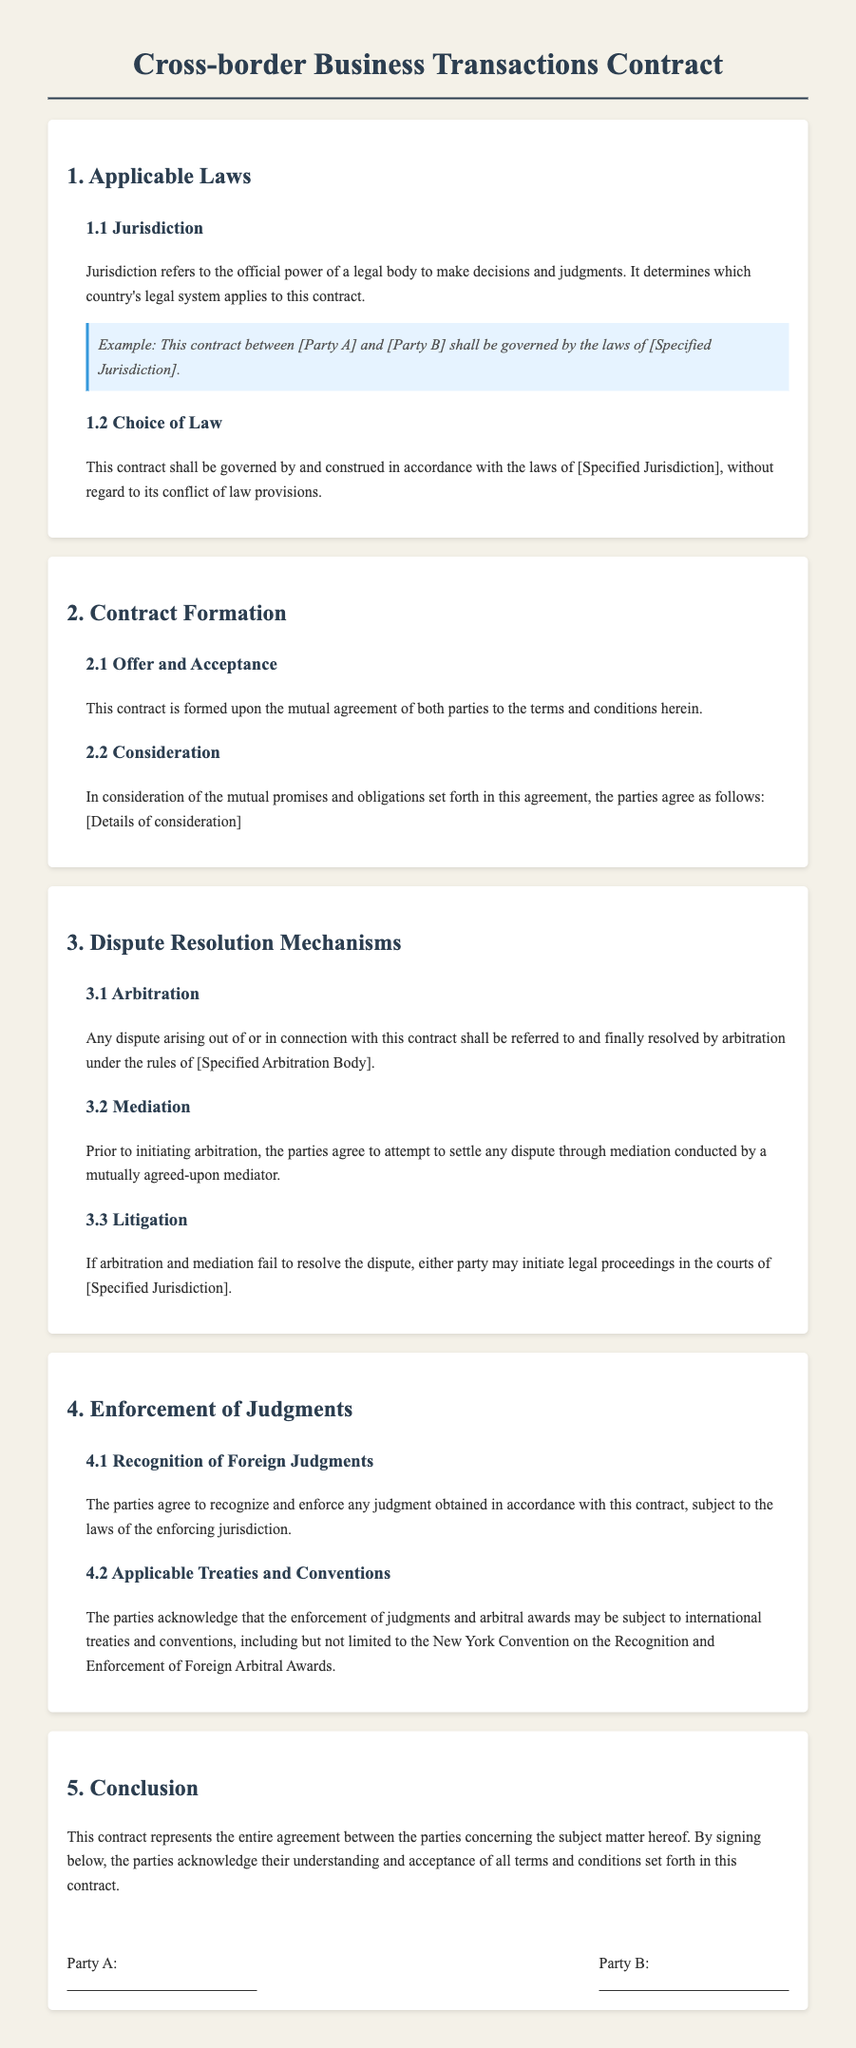What is the title of the contract? The title of the contract is highlighted at the top of the document, outlining the focus of the agreement.
Answer: Cross-border Business Transactions Contract What is specified in section 1.1? Section 1.1 discusses the concept of jurisdiction and its importance in determining the applicable legal framework for the contract.
Answer: Jurisdiction Who governs the laws applied to the contract? The document specifies who governs the laws applicable to the contract in section 1.2.
Answer: Specified Jurisdiction What dispute resolution method is mentioned first? The first dispute resolution method listed in section 3 is a process that involves an independent third party resolving a dispute.
Answer: Arbitration What is the final conclusion regarding the contract? The conclusion of the contract affirms the understanding and acceptance of all parties involved regarding its terms.
Answer: Entire agreement What is required before initiating arbitration? The document specifies a step that needs to be taken before arbitration can begin in section 3.2.
Answer: Mediation In which section is the enforcement of judgments discussed? This section discusses how judgments will be recognized and enforced based on the agreement.
Answer: Section 4 What convention is acknowledged for enforcing judgments? This international agreement mentioned in section 4.2 pertains to the recognition and enforcement of judgments and arbitral awards.
Answer: New York Convention 